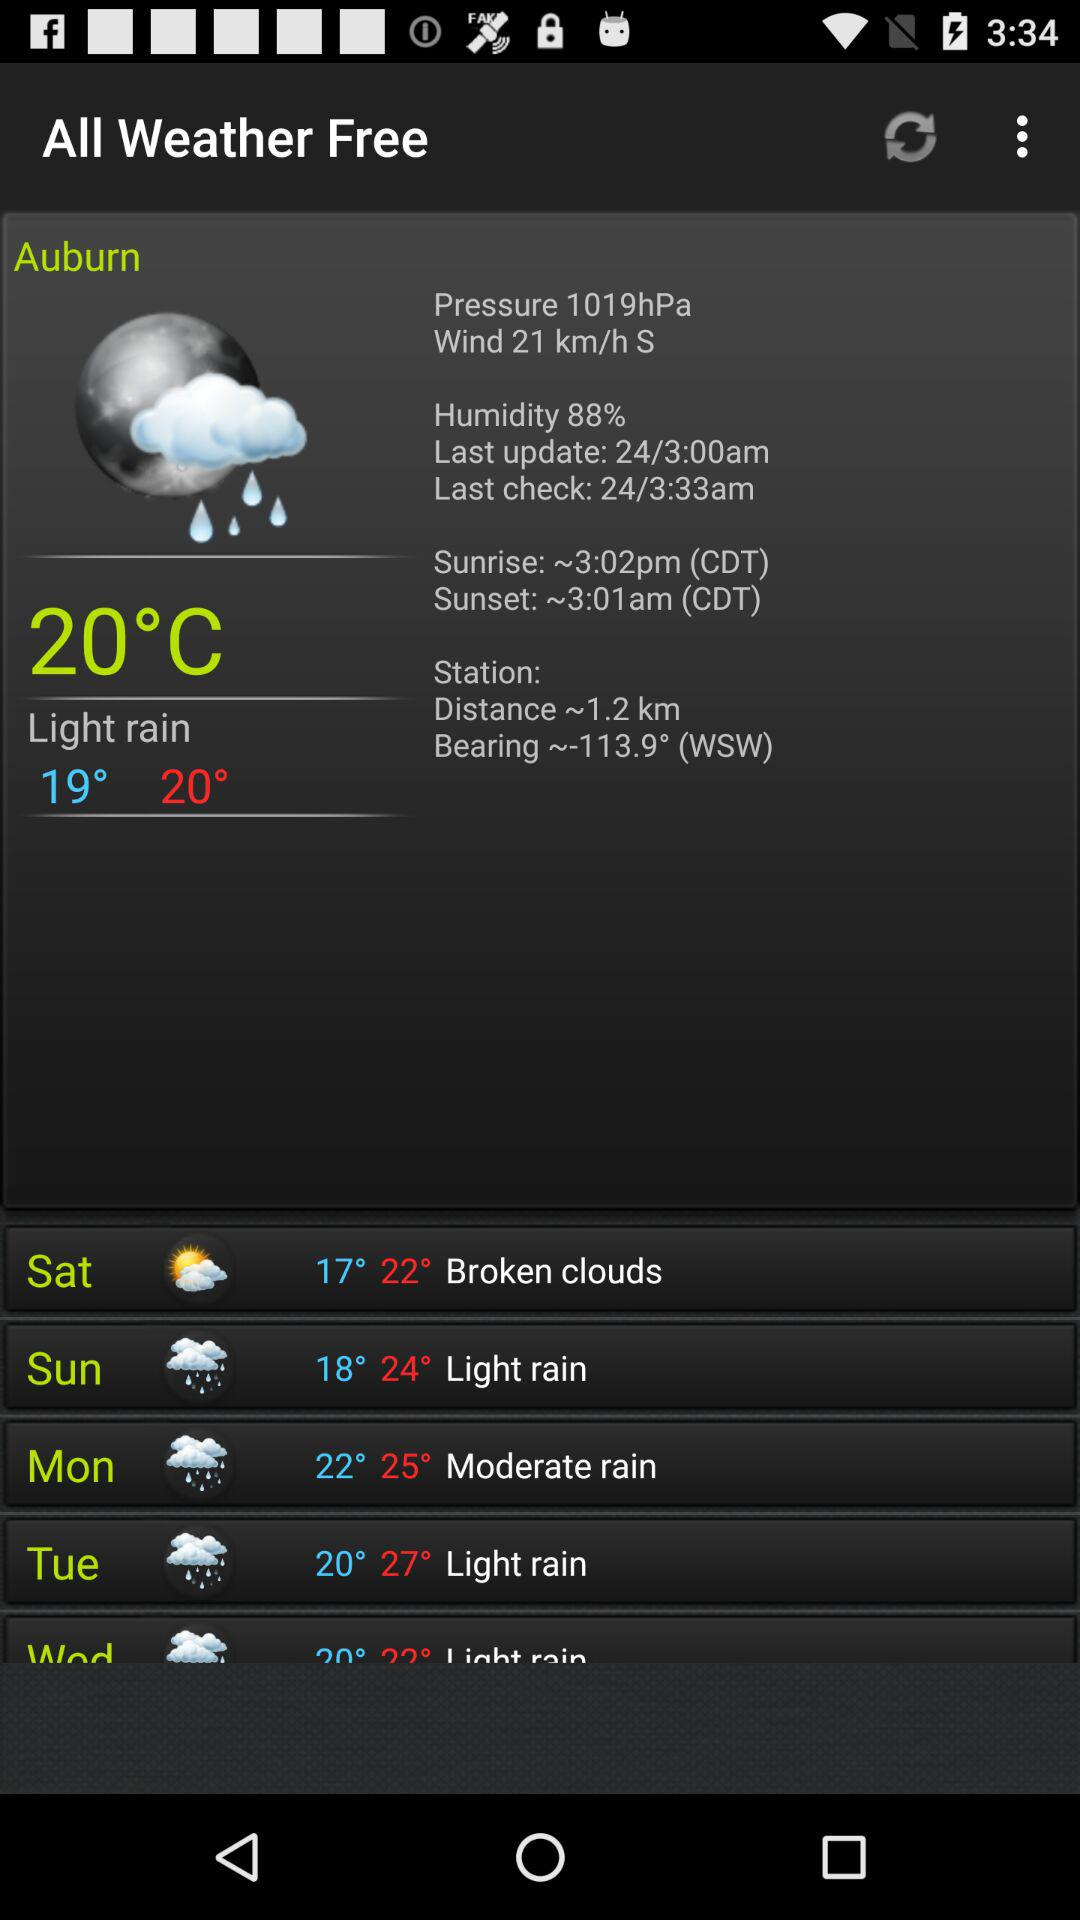What is the wind speed? The wind speed is 21 km/h S. 